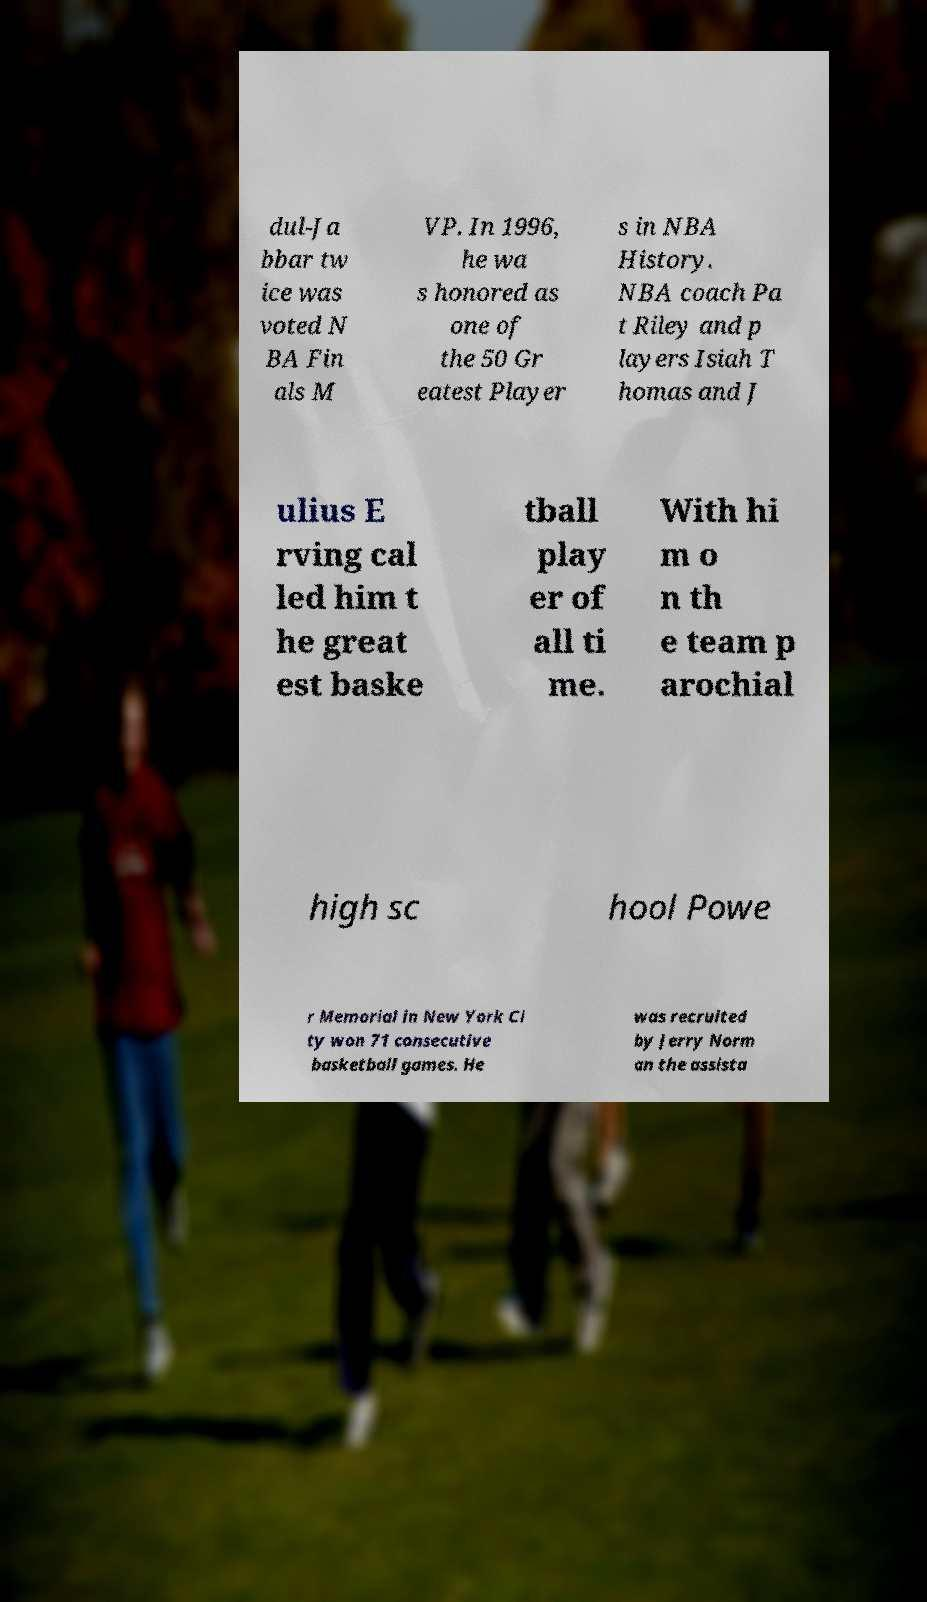Please read and relay the text visible in this image. What does it say? dul-Ja bbar tw ice was voted N BA Fin als M VP. In 1996, he wa s honored as one of the 50 Gr eatest Player s in NBA History. NBA coach Pa t Riley and p layers Isiah T homas and J ulius E rving cal led him t he great est baske tball play er of all ti me. With hi m o n th e team p arochial high sc hool Powe r Memorial in New York Ci ty won 71 consecutive basketball games. He was recruited by Jerry Norm an the assista 